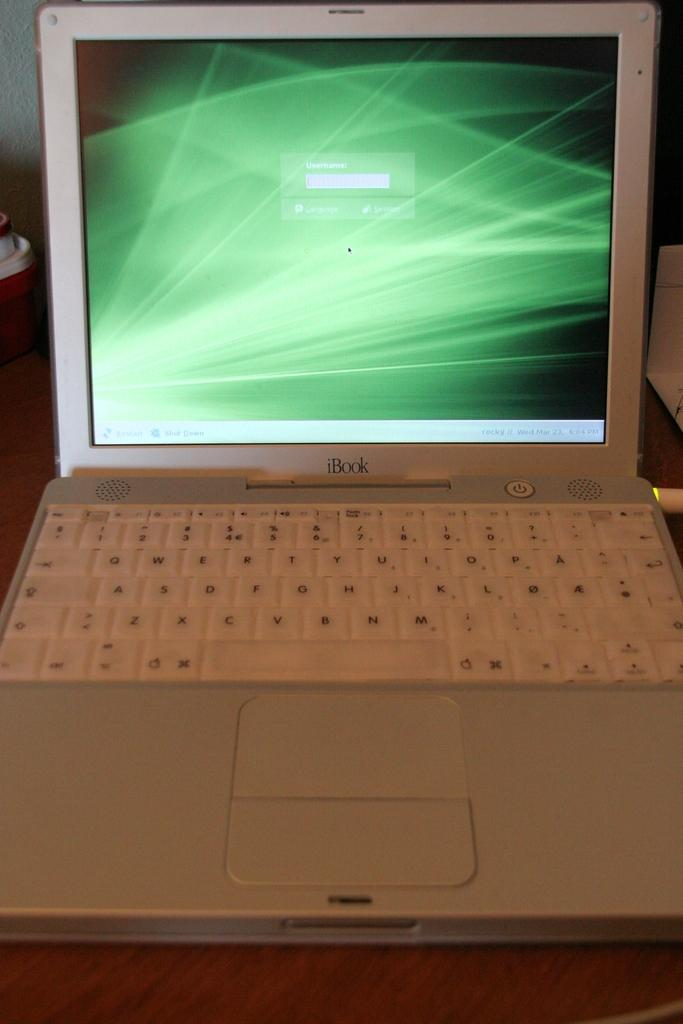<image>
Describe the image concisely. A white laptop open to a green patterned screen has the word iBook on it. 